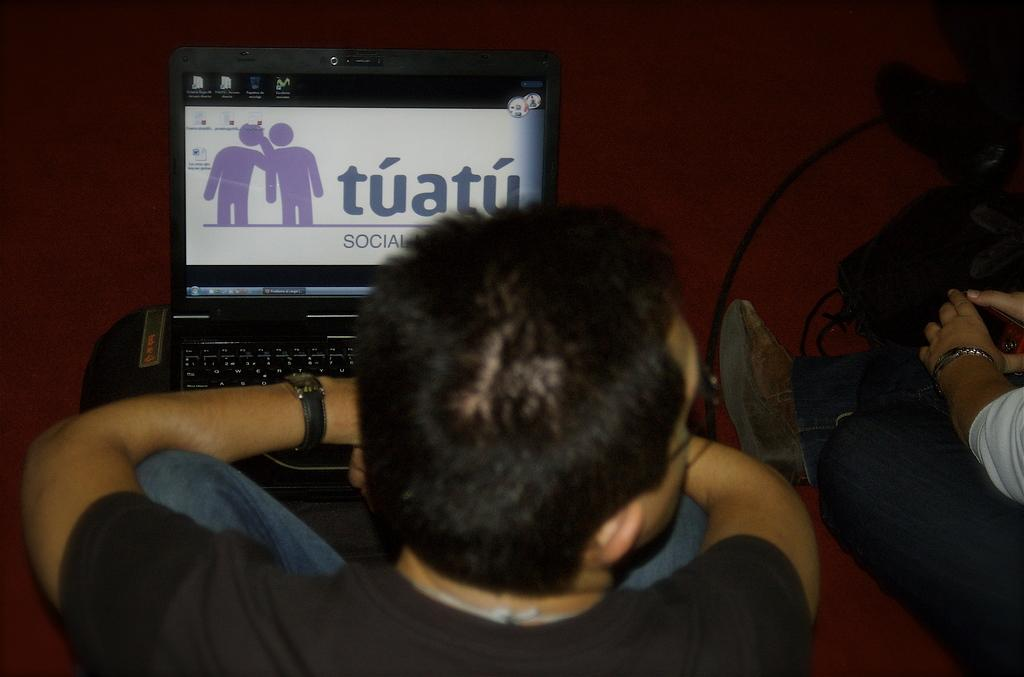Provide a one-sentence caption for the provided image. A man's laptop is open to the Tuatu website. 